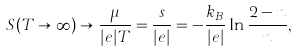Convert formula to latex. <formula><loc_0><loc_0><loc_500><loc_500>S ( T \rightarrow \infty ) \rightarrow \frac { \mu } { | e | T } = \frac { s } { | e | } = - \frac { k _ { B } } { | e | } \ln \frac { 2 - n } { n } ,</formula> 